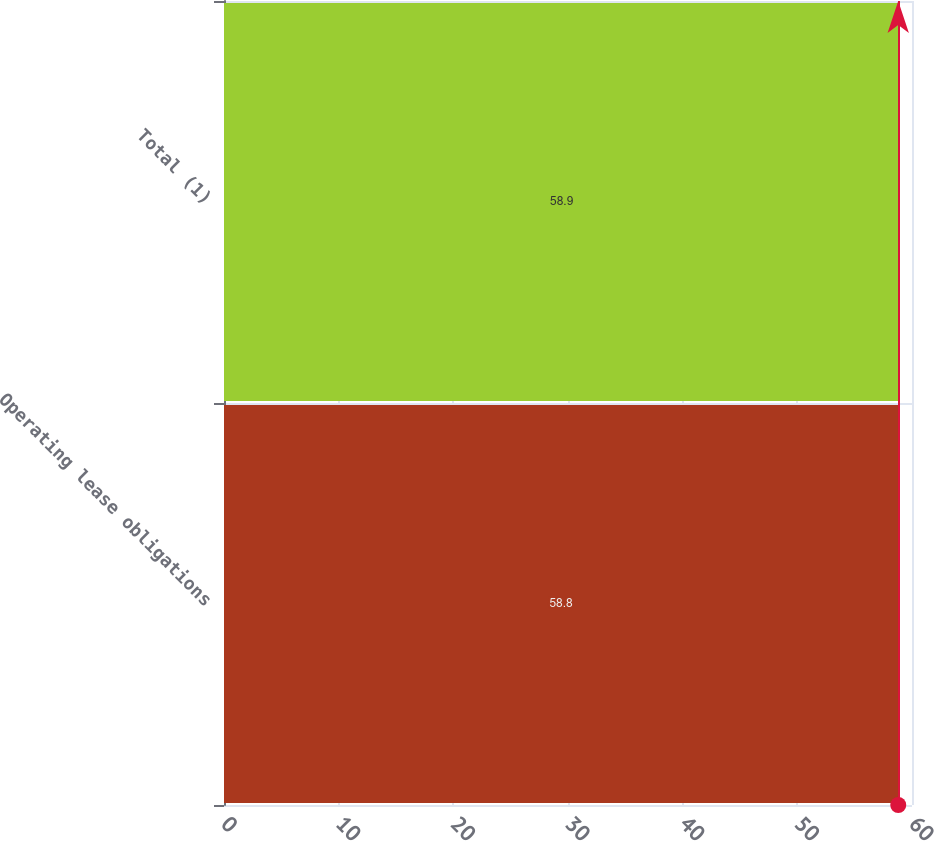<chart> <loc_0><loc_0><loc_500><loc_500><bar_chart><fcel>Operating lease obligations<fcel>Total (1)<nl><fcel>58.8<fcel>58.9<nl></chart> 